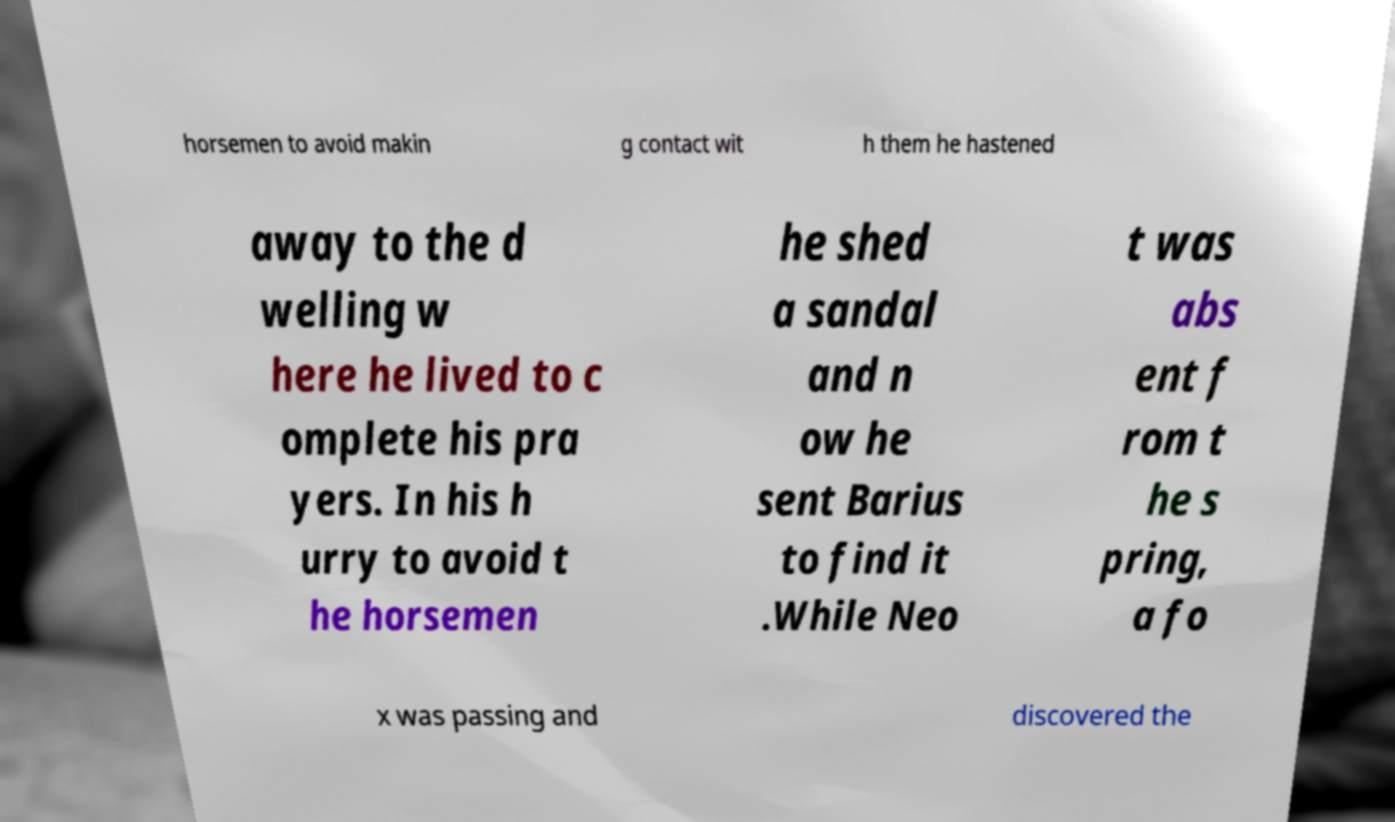Can you accurately transcribe the text from the provided image for me? horsemen to avoid makin g contact wit h them he hastened away to the d welling w here he lived to c omplete his pra yers. In his h urry to avoid t he horsemen he shed a sandal and n ow he sent Barius to find it .While Neo t was abs ent f rom t he s pring, a fo x was passing and discovered the 